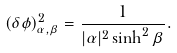Convert formula to latex. <formula><loc_0><loc_0><loc_500><loc_500>( \delta \phi ) ^ { 2 } _ { \alpha , \beta } = \frac { 1 } { | \alpha | ^ { 2 } \sinh ^ { 2 } \beta } .</formula> 